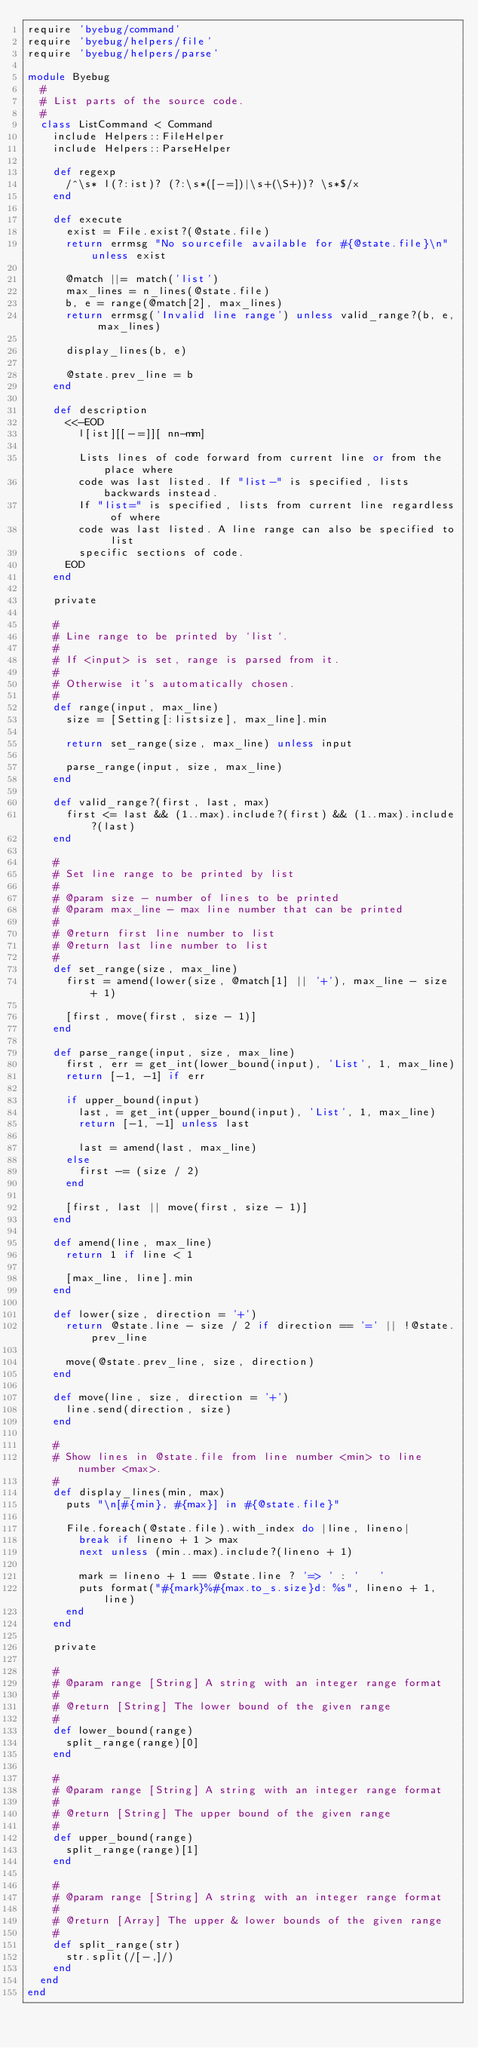<code> <loc_0><loc_0><loc_500><loc_500><_Ruby_>require 'byebug/command'
require 'byebug/helpers/file'
require 'byebug/helpers/parse'

module Byebug
  #
  # List parts of the source code.
  #
  class ListCommand < Command
    include Helpers::FileHelper
    include Helpers::ParseHelper

    def regexp
      /^\s* l(?:ist)? (?:\s*([-=])|\s+(\S+))? \s*$/x
    end

    def execute
      exist = File.exist?(@state.file)
      return errmsg "No sourcefile available for #{@state.file}\n" unless exist

      @match ||= match('list')
      max_lines = n_lines(@state.file)
      b, e = range(@match[2], max_lines)
      return errmsg('Invalid line range') unless valid_range?(b, e, max_lines)

      display_lines(b, e)

      @state.prev_line = b
    end

    def description
      <<-EOD
        l[ist][[-=]][ nn-mm]

        Lists lines of code forward from current line or from the place where
        code was last listed. If "list-" is specified, lists backwards instead.
        If "list=" is specified, lists from current line regardless of where
        code was last listed. A line range can also be specified to list
        specific sections of code.
      EOD
    end

    private

    #
    # Line range to be printed by `list`.
    #
    # If <input> is set, range is parsed from it.
    #
    # Otherwise it's automatically chosen.
    #
    def range(input, max_line)
      size = [Setting[:listsize], max_line].min

      return set_range(size, max_line) unless input

      parse_range(input, size, max_line)
    end

    def valid_range?(first, last, max)
      first <= last && (1..max).include?(first) && (1..max).include?(last)
    end

    #
    # Set line range to be printed by list
    #
    # @param size - number of lines to be printed
    # @param max_line - max line number that can be printed
    #
    # @return first line number to list
    # @return last line number to list
    #
    def set_range(size, max_line)
      first = amend(lower(size, @match[1] || '+'), max_line - size + 1)

      [first, move(first, size - 1)]
    end

    def parse_range(input, size, max_line)
      first, err = get_int(lower_bound(input), 'List', 1, max_line)
      return [-1, -1] if err

      if upper_bound(input)
        last, = get_int(upper_bound(input), 'List', 1, max_line)
        return [-1, -1] unless last

        last = amend(last, max_line)
      else
        first -= (size / 2)
      end

      [first, last || move(first, size - 1)]
    end

    def amend(line, max_line)
      return 1 if line < 1

      [max_line, line].min
    end

    def lower(size, direction = '+')
      return @state.line - size / 2 if direction == '=' || !@state.prev_line

      move(@state.prev_line, size, direction)
    end

    def move(line, size, direction = '+')
      line.send(direction, size)
    end

    #
    # Show lines in @state.file from line number <min> to line number <max>.
    #
    def display_lines(min, max)
      puts "\n[#{min}, #{max}] in #{@state.file}"

      File.foreach(@state.file).with_index do |line, lineno|
        break if lineno + 1 > max
        next unless (min..max).include?(lineno + 1)

        mark = lineno + 1 == @state.line ? '=> ' : '   '
        puts format("#{mark}%#{max.to_s.size}d: %s", lineno + 1, line)
      end
    end

    private

    #
    # @param range [String] A string with an integer range format
    #
    # @return [String] The lower bound of the given range
    #
    def lower_bound(range)
      split_range(range)[0]
    end

    #
    # @param range [String] A string with an integer range format
    #
    # @return [String] The upper bound of the given range
    #
    def upper_bound(range)
      split_range(range)[1]
    end

    #
    # @param range [String] A string with an integer range format
    #
    # @return [Array] The upper & lower bounds of the given range
    #
    def split_range(str)
      str.split(/[-,]/)
    end
  end
end
</code> 